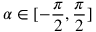<formula> <loc_0><loc_0><loc_500><loc_500>\alpha \in [ - \frac { \pi } { 2 } , \frac { \pi } { 2 } ]</formula> 